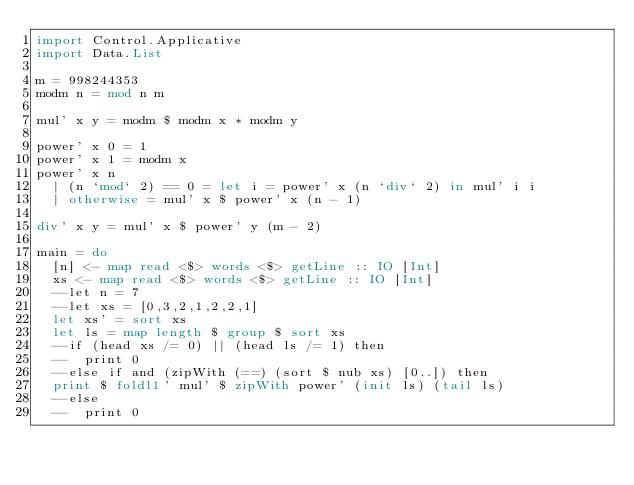<code> <loc_0><loc_0><loc_500><loc_500><_Haskell_>import Control.Applicative
import Data.List

m = 998244353
modm n = mod n m

mul' x y = modm $ modm x * modm y

power' x 0 = 1
power' x 1 = modm x
power' x n
  | (n `mod` 2) == 0 = let i = power' x (n `div` 2) in mul' i i
  | otherwise = mul' x $ power' x (n - 1)

div' x y = mul' x $ power' y (m - 2)

main = do
  [n] <- map read <$> words <$> getLine :: IO [Int]
  xs <- map read <$> words <$> getLine :: IO [Int]
  --let n = 7
  --let xs = [0,3,2,1,2,2,1]
  let xs' = sort xs
  let ls = map length $ group $ sort xs
  --if (head xs /= 0) || (head ls /= 1) then
  --  print 0
  --else if and (zipWith (==) (sort $ nub xs) [0..]) then
  print $ foldl1' mul' $ zipWith power' (init ls) (tail ls)
  --else
  --  print 0

</code> 